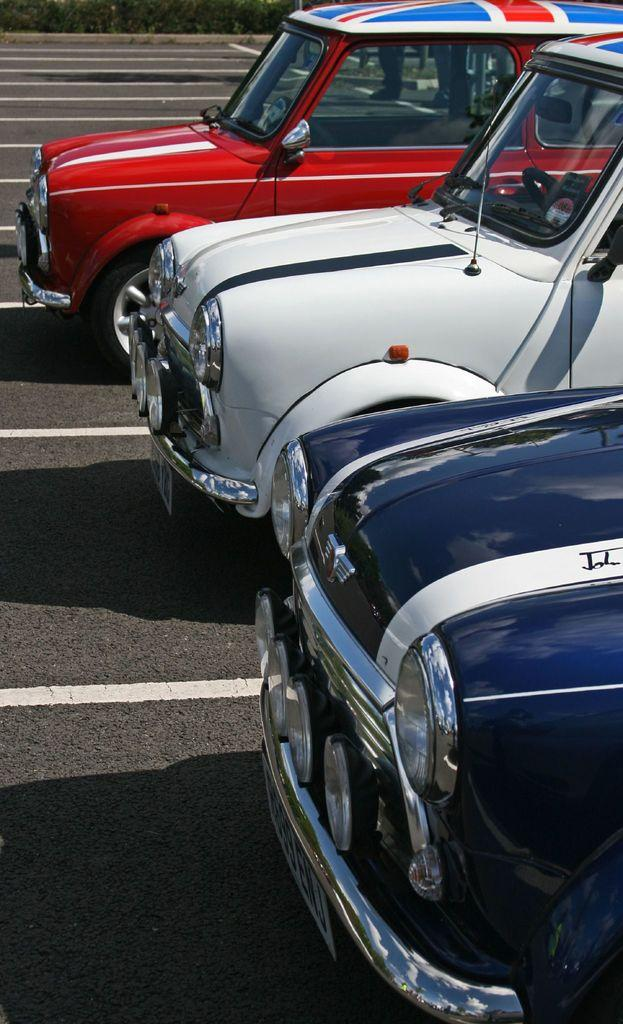How many cars can be seen in the image? There are three cars in the image. Where are the cars located? The cars are on the road. What can be observed on the road in the image? There are white color lines on the road. What type of scene is depicted in the image? The image does not depict a scene; it is a photograph of three cars on a road with white color lines. Can you tell me who provided the credit for the image? There is no information about the credit for the image in the provided facts. 